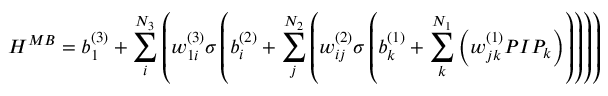<formula> <loc_0><loc_0><loc_500><loc_500>H ^ { M B } = b _ { 1 } ^ { ( 3 ) } + \sum _ { i } ^ { N _ { 3 } } \left ( w _ { 1 i } ^ { ( 3 ) } \sigma \left ( b _ { i } ^ { ( 2 ) } + \sum _ { j } ^ { N _ { 2 } } \left ( w _ { i j } ^ { ( 2 ) } \sigma \left ( b _ { k } ^ { ( 1 ) } + \sum _ { k } ^ { N _ { 1 } } \left ( w _ { j k } ^ { ( 1 ) } P I P _ { k } \right ) \right ) \right ) \right ) \right )</formula> 